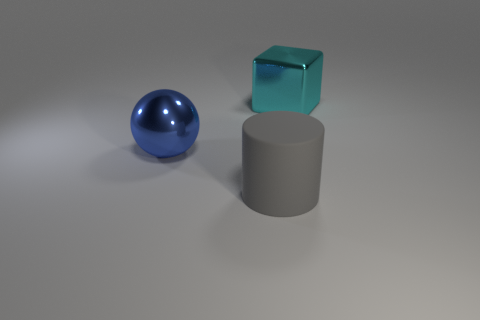Are there any other things that have the same material as the big gray cylinder?
Make the answer very short. No. Are there any other things that have the same shape as the gray thing?
Offer a terse response. No. There is a shiny thing left of the cyan object; is its color the same as the metallic thing on the right side of the gray object?
Provide a short and direct response. No. Are there fewer cyan metallic cubes behind the big metal block than large cubes on the left side of the large blue ball?
Provide a succinct answer. No. There is a big metallic object to the right of the gray object; what shape is it?
Your answer should be compact. Cube. What number of other things are there of the same material as the cylinder
Your answer should be very brief. 0. Do the blue metal thing and the big metal thing right of the big rubber thing have the same shape?
Keep it short and to the point. No. What shape is the large thing that is made of the same material as the ball?
Keep it short and to the point. Cube. Are there more large rubber cylinders on the right side of the rubber cylinder than gray objects that are behind the blue shiny object?
Offer a very short reply. No. What number of objects are either small metal cubes or big shiny objects?
Give a very brief answer. 2. 